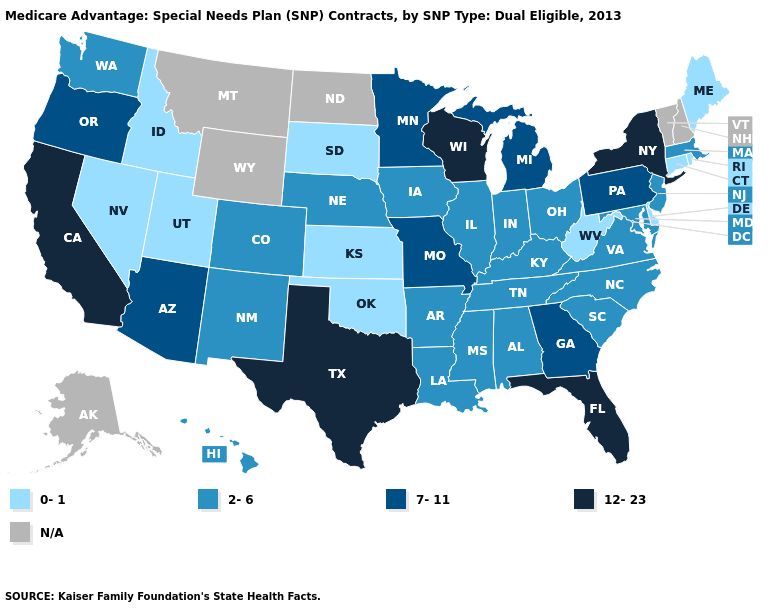What is the highest value in the South ?
Short answer required. 12-23. Name the states that have a value in the range 12-23?
Concise answer only. California, Florida, New York, Texas, Wisconsin. How many symbols are there in the legend?
Write a very short answer. 5. Name the states that have a value in the range 7-11?
Keep it brief. Arizona, Georgia, Michigan, Minnesota, Missouri, Oregon, Pennsylvania. Which states hav the highest value in the West?
Be succinct. California. Which states have the lowest value in the MidWest?
Concise answer only. Kansas, South Dakota. Does Idaho have the lowest value in the USA?
Concise answer only. Yes. What is the highest value in the South ?
Give a very brief answer. 12-23. Does Mississippi have the lowest value in the South?
Short answer required. No. Name the states that have a value in the range 2-6?
Quick response, please. Alabama, Arkansas, Colorado, Hawaii, Iowa, Illinois, Indiana, Kentucky, Louisiana, Massachusetts, Maryland, Mississippi, North Carolina, Nebraska, New Jersey, New Mexico, Ohio, South Carolina, Tennessee, Virginia, Washington. Among the states that border New Hampshire , which have the highest value?
Write a very short answer. Massachusetts. Name the states that have a value in the range 7-11?
Write a very short answer. Arizona, Georgia, Michigan, Minnesota, Missouri, Oregon, Pennsylvania. What is the highest value in the USA?
Give a very brief answer. 12-23. Among the states that border Massachusetts , which have the lowest value?
Give a very brief answer. Connecticut, Rhode Island. 